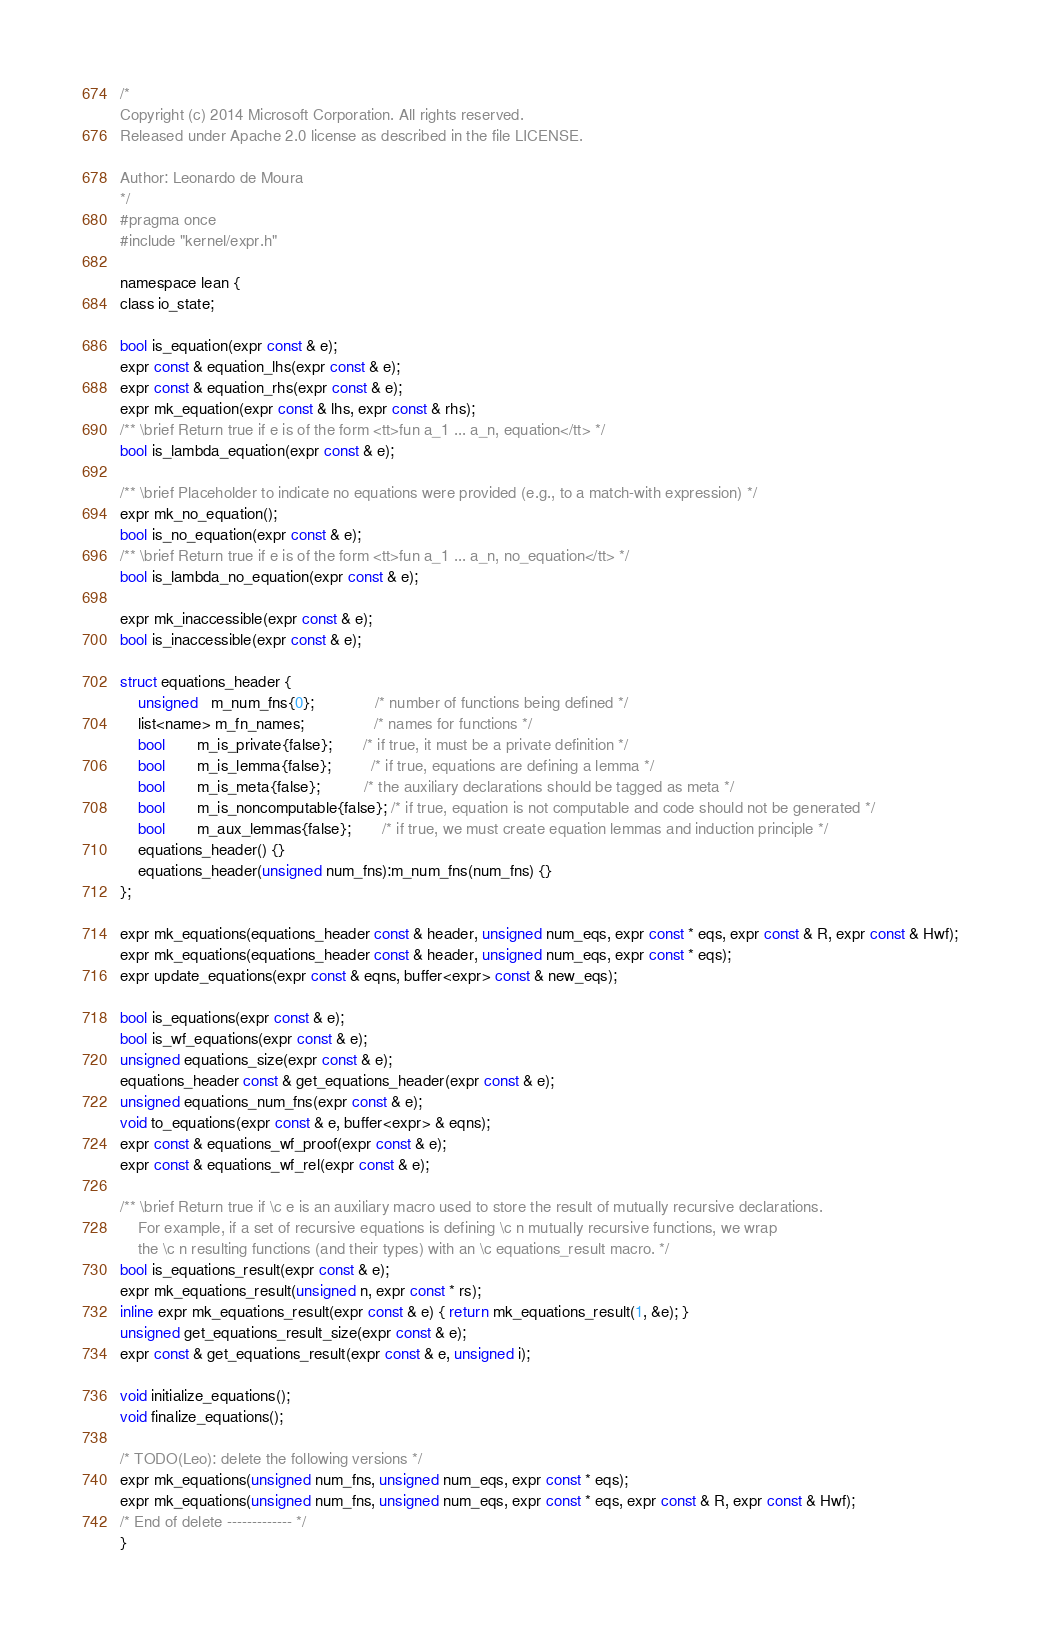Convert code to text. <code><loc_0><loc_0><loc_500><loc_500><_C_>/*
Copyright (c) 2014 Microsoft Corporation. All rights reserved.
Released under Apache 2.0 license as described in the file LICENSE.

Author: Leonardo de Moura
*/
#pragma once
#include "kernel/expr.h"

namespace lean {
class io_state;

bool is_equation(expr const & e);
expr const & equation_lhs(expr const & e);
expr const & equation_rhs(expr const & e);
expr mk_equation(expr const & lhs, expr const & rhs);
/** \brief Return true if e is of the form <tt>fun a_1 ... a_n, equation</tt> */
bool is_lambda_equation(expr const & e);

/** \brief Placeholder to indicate no equations were provided (e.g., to a match-with expression) */
expr mk_no_equation();
bool is_no_equation(expr const & e);
/** \brief Return true if e is of the form <tt>fun a_1 ... a_n, no_equation</tt> */
bool is_lambda_no_equation(expr const & e);

expr mk_inaccessible(expr const & e);
bool is_inaccessible(expr const & e);

struct equations_header {
    unsigned   m_num_fns{0};              /* number of functions being defined */
    list<name> m_fn_names;                /* names for functions */
    bool       m_is_private{false};       /* if true, it must be a private definition */
    bool       m_is_lemma{false};         /* if true, equations are defining a lemma */
    bool       m_is_meta{false};          /* the auxiliary declarations should be tagged as meta */
    bool       m_is_noncomputable{false}; /* if true, equation is not computable and code should not be generated */
    bool       m_aux_lemmas{false};       /* if true, we must create equation lemmas and induction principle */
    equations_header() {}
    equations_header(unsigned num_fns):m_num_fns(num_fns) {}
};

expr mk_equations(equations_header const & header, unsigned num_eqs, expr const * eqs, expr const & R, expr const & Hwf);
expr mk_equations(equations_header const & header, unsigned num_eqs, expr const * eqs);
expr update_equations(expr const & eqns, buffer<expr> const & new_eqs);

bool is_equations(expr const & e);
bool is_wf_equations(expr const & e);
unsigned equations_size(expr const & e);
equations_header const & get_equations_header(expr const & e);
unsigned equations_num_fns(expr const & e);
void to_equations(expr const & e, buffer<expr> & eqns);
expr const & equations_wf_proof(expr const & e);
expr const & equations_wf_rel(expr const & e);

/** \brief Return true if \c e is an auxiliary macro used to store the result of mutually recursive declarations.
    For example, if a set of recursive equations is defining \c n mutually recursive functions, we wrap
    the \c n resulting functions (and their types) with an \c equations_result macro. */
bool is_equations_result(expr const & e);
expr mk_equations_result(unsigned n, expr const * rs);
inline expr mk_equations_result(expr const & e) { return mk_equations_result(1, &e); }
unsigned get_equations_result_size(expr const & e);
expr const & get_equations_result(expr const & e, unsigned i);

void initialize_equations();
void finalize_equations();

/* TODO(Leo): delete the following versions */
expr mk_equations(unsigned num_fns, unsigned num_eqs, expr const * eqs);
expr mk_equations(unsigned num_fns, unsigned num_eqs, expr const * eqs, expr const & R, expr const & Hwf);
/* End of delete ------------- */
}
</code> 